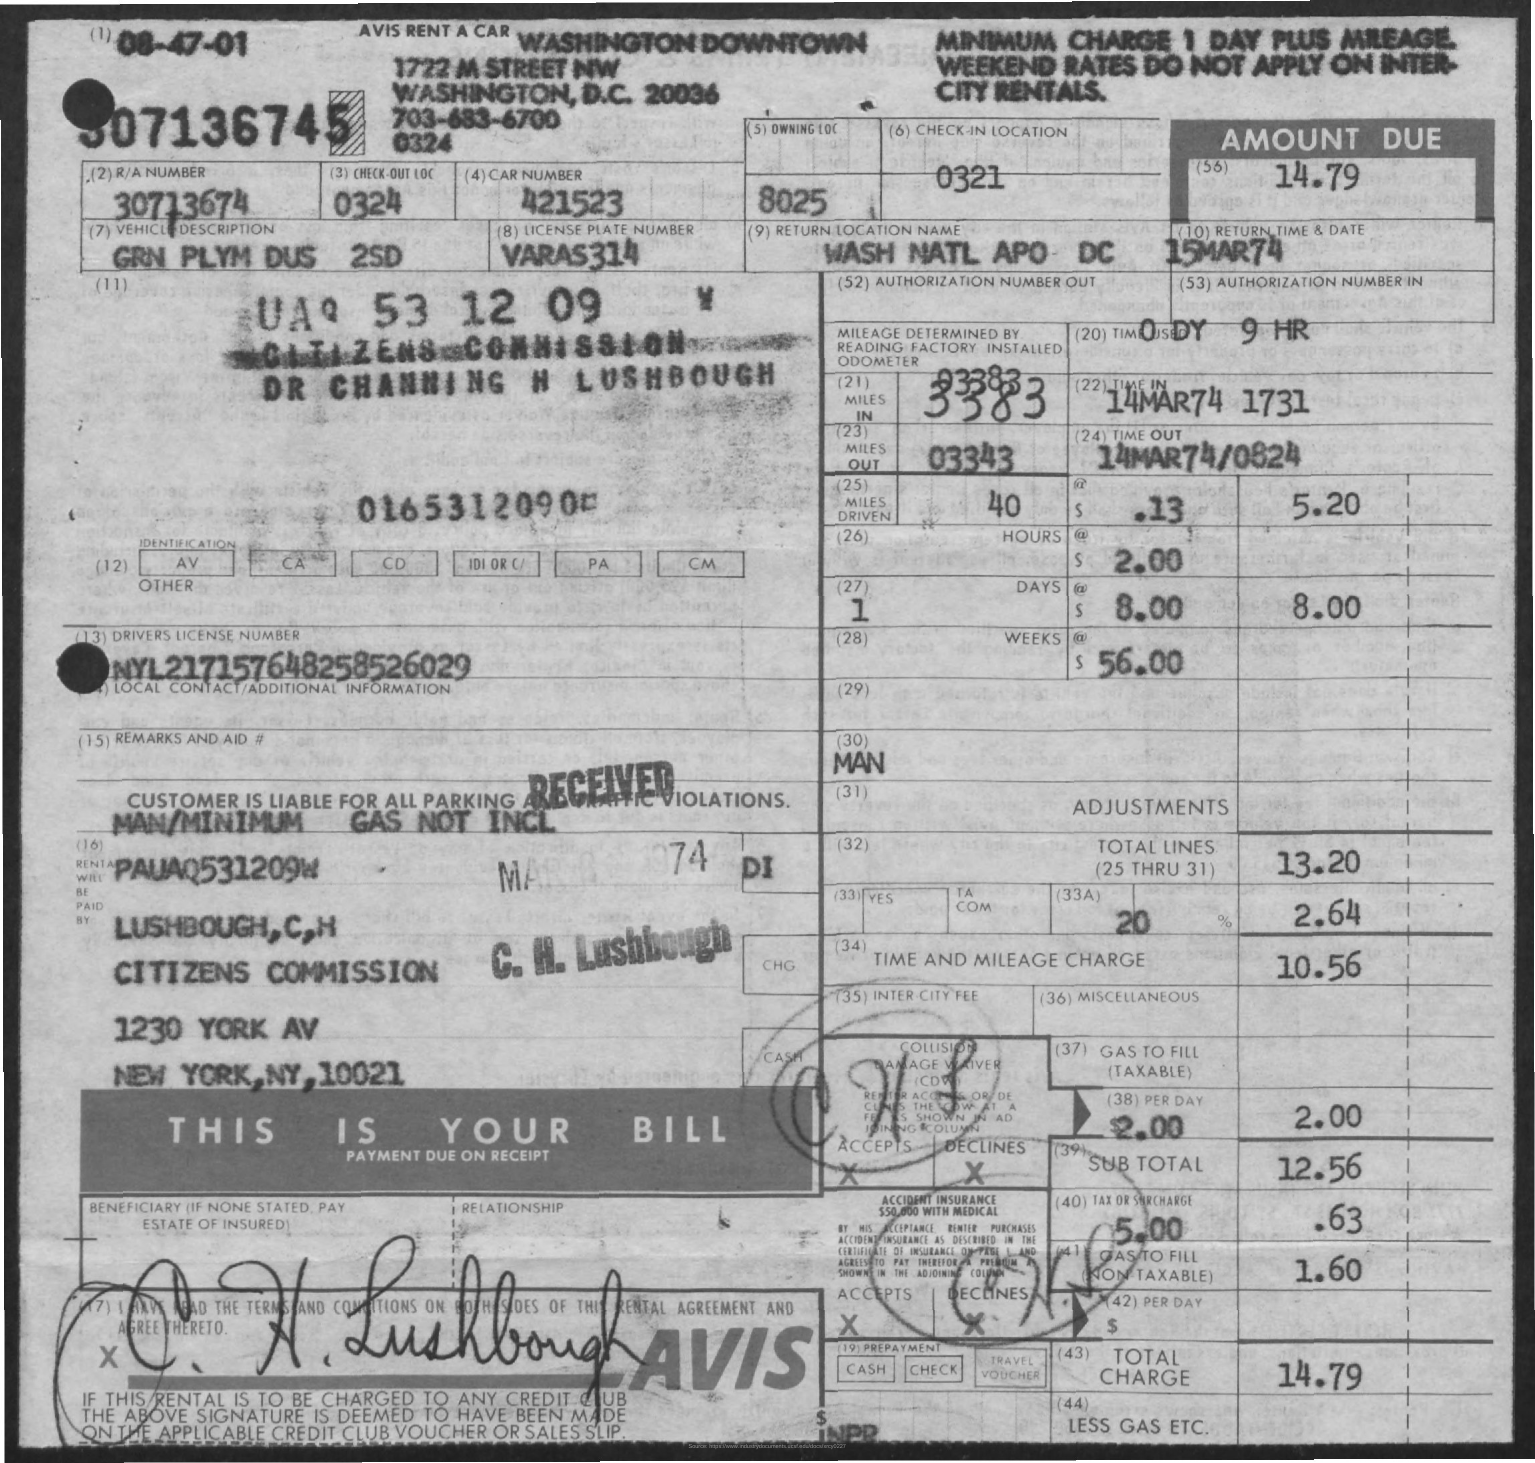What is the R/A Number?
Your answer should be very brief. 30713674. What is the Car Number?
Keep it short and to the point. 421523. What is the Check-out LOC?
Ensure brevity in your answer.  324. What is the Return Location Name?
Make the answer very short. Wash natl apo dc. What is the Return Date?
Your answer should be very brief. 15MAR74. 